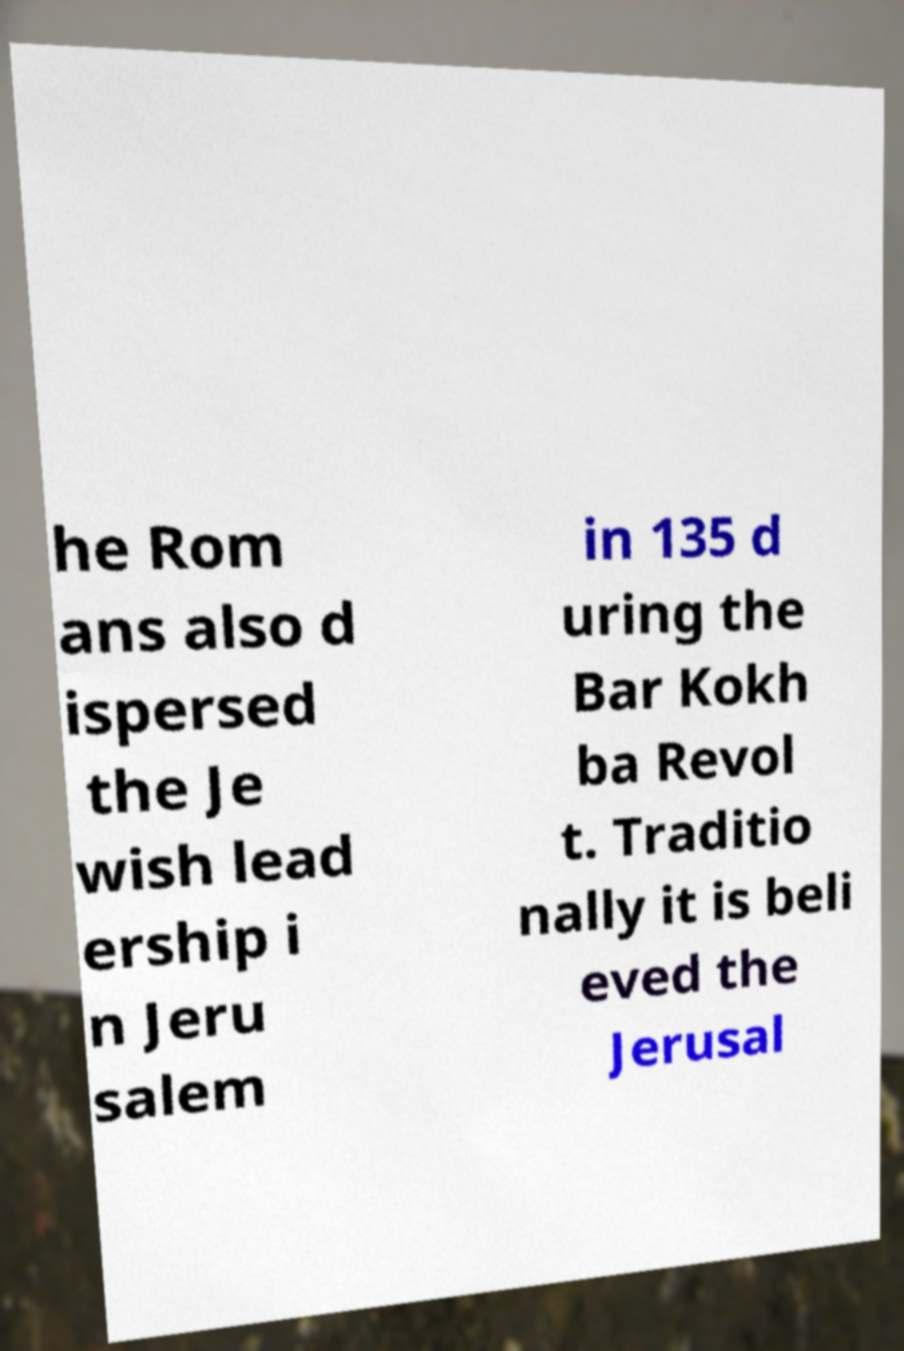I need the written content from this picture converted into text. Can you do that? he Rom ans also d ispersed the Je wish lead ership i n Jeru salem in 135 d uring the Bar Kokh ba Revol t. Traditio nally it is beli eved the Jerusal 